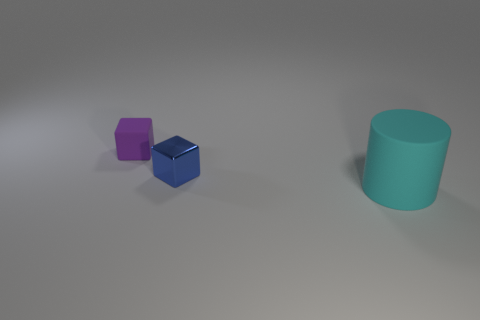Add 3 tiny yellow metallic objects. How many objects exist? 6 Subtract all blocks. How many objects are left? 1 Add 1 small purple matte things. How many small purple matte things are left? 2 Add 3 big rubber cylinders. How many big rubber cylinders exist? 4 Subtract 1 purple cubes. How many objects are left? 2 Subtract all large rubber cylinders. Subtract all purple things. How many objects are left? 1 